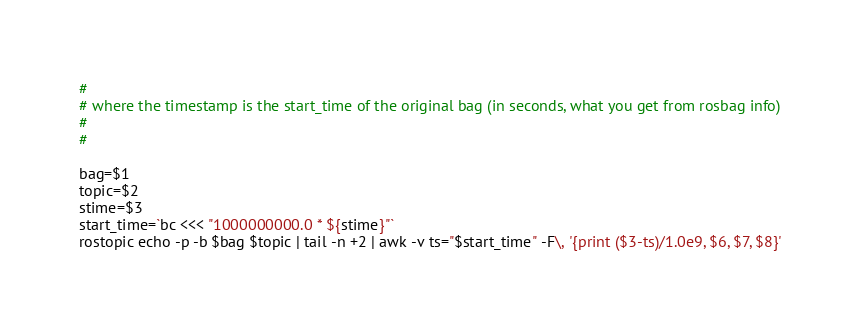Convert code to text. <code><loc_0><loc_0><loc_500><loc_500><_Bash_>#
# where the timestamp is the start_time of the original bag (in seconds, what you get from rosbag info)
#
#

bag=$1
topic=$2
stime=$3
start_time=`bc <<< "1000000000.0 * ${stime}"`
rostopic echo -p -b $bag $topic | tail -n +2 | awk -v ts="$start_time" -F\, '{print ($3-ts)/1.0e9, $6, $7, $8}'
</code> 